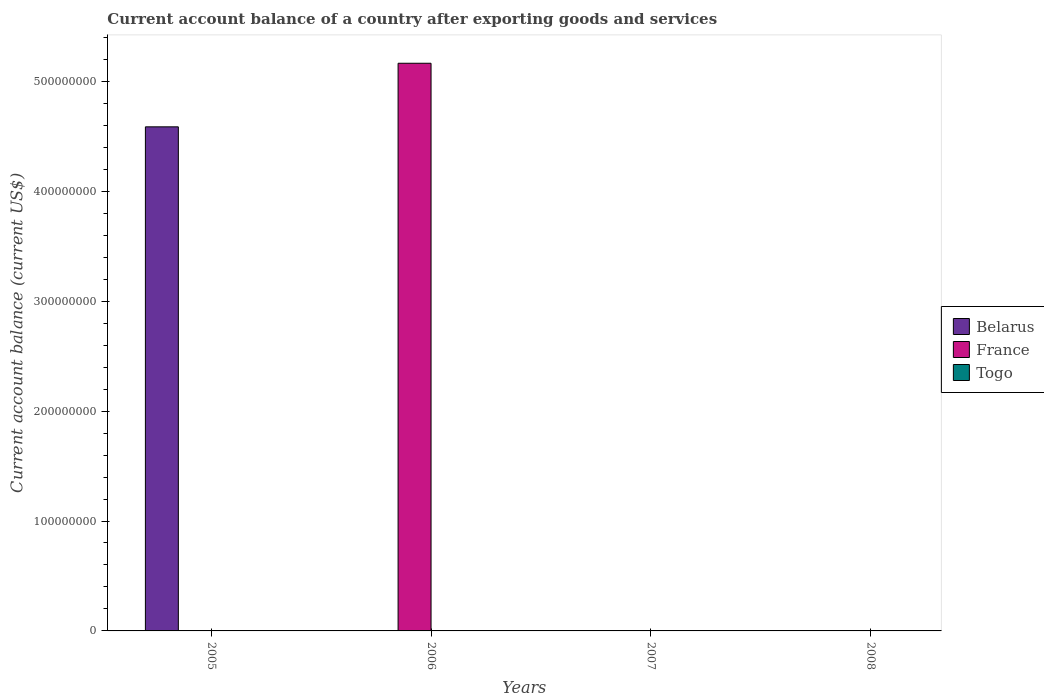How many different coloured bars are there?
Provide a short and direct response. 2. Are the number of bars per tick equal to the number of legend labels?
Make the answer very short. No. How many bars are there on the 2nd tick from the left?
Make the answer very short. 1. How many bars are there on the 4th tick from the right?
Your response must be concise. 1. Across all years, what is the maximum account balance in Belarus?
Your response must be concise. 4.59e+08. Across all years, what is the minimum account balance in Togo?
Your answer should be compact. 0. In which year was the account balance in Belarus maximum?
Offer a terse response. 2005. What is the total account balance in Belarus in the graph?
Make the answer very short. 4.59e+08. What is the difference between the account balance in Belarus in 2005 and the account balance in Togo in 2006?
Your response must be concise. 4.59e+08. In how many years, is the account balance in Belarus greater than 380000000 US$?
Provide a short and direct response. 1. What is the difference between the highest and the lowest account balance in Belarus?
Ensure brevity in your answer.  4.59e+08. Is it the case that in every year, the sum of the account balance in Belarus and account balance in France is greater than the account balance in Togo?
Make the answer very short. No. What is the difference between two consecutive major ticks on the Y-axis?
Your answer should be compact. 1.00e+08. Are the values on the major ticks of Y-axis written in scientific E-notation?
Provide a short and direct response. No. Where does the legend appear in the graph?
Keep it short and to the point. Center right. What is the title of the graph?
Give a very brief answer. Current account balance of a country after exporting goods and services. Does "Small states" appear as one of the legend labels in the graph?
Your answer should be compact. No. What is the label or title of the Y-axis?
Your response must be concise. Current account balance (current US$). What is the Current account balance (current US$) in Belarus in 2005?
Ensure brevity in your answer.  4.59e+08. What is the Current account balance (current US$) in Togo in 2005?
Your answer should be compact. 0. What is the Current account balance (current US$) in France in 2006?
Keep it short and to the point. 5.16e+08. What is the Current account balance (current US$) in France in 2007?
Give a very brief answer. 0. What is the Current account balance (current US$) in Togo in 2007?
Offer a very short reply. 0. What is the Current account balance (current US$) in Togo in 2008?
Offer a very short reply. 0. Across all years, what is the maximum Current account balance (current US$) in Belarus?
Your answer should be compact. 4.59e+08. Across all years, what is the maximum Current account balance (current US$) of France?
Ensure brevity in your answer.  5.16e+08. What is the total Current account balance (current US$) of Belarus in the graph?
Provide a short and direct response. 4.59e+08. What is the total Current account balance (current US$) in France in the graph?
Ensure brevity in your answer.  5.16e+08. What is the difference between the Current account balance (current US$) in Belarus in 2005 and the Current account balance (current US$) in France in 2006?
Keep it short and to the point. -5.78e+07. What is the average Current account balance (current US$) of Belarus per year?
Your answer should be very brief. 1.15e+08. What is the average Current account balance (current US$) of France per year?
Your answer should be very brief. 1.29e+08. What is the average Current account balance (current US$) of Togo per year?
Make the answer very short. 0. What is the difference between the highest and the lowest Current account balance (current US$) of Belarus?
Offer a terse response. 4.59e+08. What is the difference between the highest and the lowest Current account balance (current US$) in France?
Your answer should be very brief. 5.16e+08. 